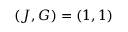Convert formula to latex. <formula><loc_0><loc_0><loc_500><loc_500>( J , G ) = ( 1 , 1 )</formula> 